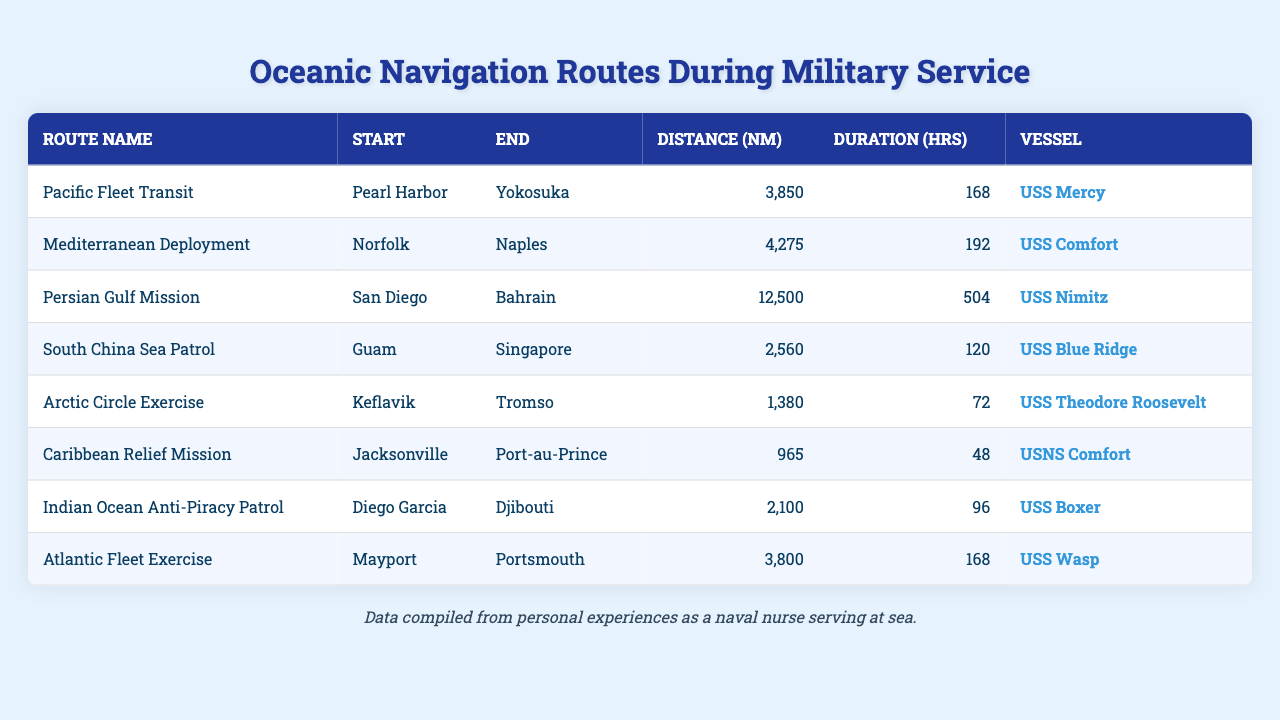What is the longest navigation route listed in the table? The table provides several routes, and by inspecting the distance column, the Persian Gulf Mission has the longest distance of 12,500 nautical miles.
Answer: 12,500 nautical miles Which vessel traveled the shortest distance? Looking at the distance values in the table, the Caribbean Relief Mission had the shortest distance of 965 nautical miles, and the vessel involved was the USNS Comfort.
Answer: USNS Comfort How many hours did the South China Sea Patrol take? According to the duration column, the South China Sea Patrol took 120 hours to complete.
Answer: 120 hours What is the total distance covered by all routes? Summing the distances from the table gives: 3,850 + 4,275 + 12,500 + 2,560 + 1,380 + 965 + 2,100 + 3,800 = 31,430 nautical miles.
Answer: 31,430 nautical miles Is the duration of the Arctic Circle Exercise less than 100 hours? Checking the duration for the Arctic Circle Exercise, which is 72 hours, confirms that it is indeed less than 100 hours.
Answer: Yes Which route had the highest duration and what was it? Comparing the duration values, the Persian Gulf Mission had the highest duration of 504 hours.
Answer: Persian Gulf Mission, 504 hours What is the average distance of the routes listed? To find the average distance, first sum up all distances (31,430) and divide by the number of routes (8), resulting in an average distance of 3,928.75 nautical miles.
Answer: 3,928.75 nautical miles Are there any routes starting from Davis’s location? Since the table does not list any starting points that would indicate “Davis,” it is correct to say there are no such routes.
Answer: No What is the combined duration of the Pacific Fleet Transit and Caribbean Relief Mission? Summing the durations of these two routes gives: 168 hours (Pacific Fleet Transit) + 48 hours (Caribbean Relief Mission) = 216 hours.
Answer: 216 hours Which two routes together cover less than 5,000 nautical miles? By examining the distances, the Arctic Circle Exercise (1,380) and Caribbean Relief Mission (965) total 2,345 nautical miles, which is less than 5,000 nautical miles.
Answer: Arctic Circle Exercise and Caribbean Relief Mission 